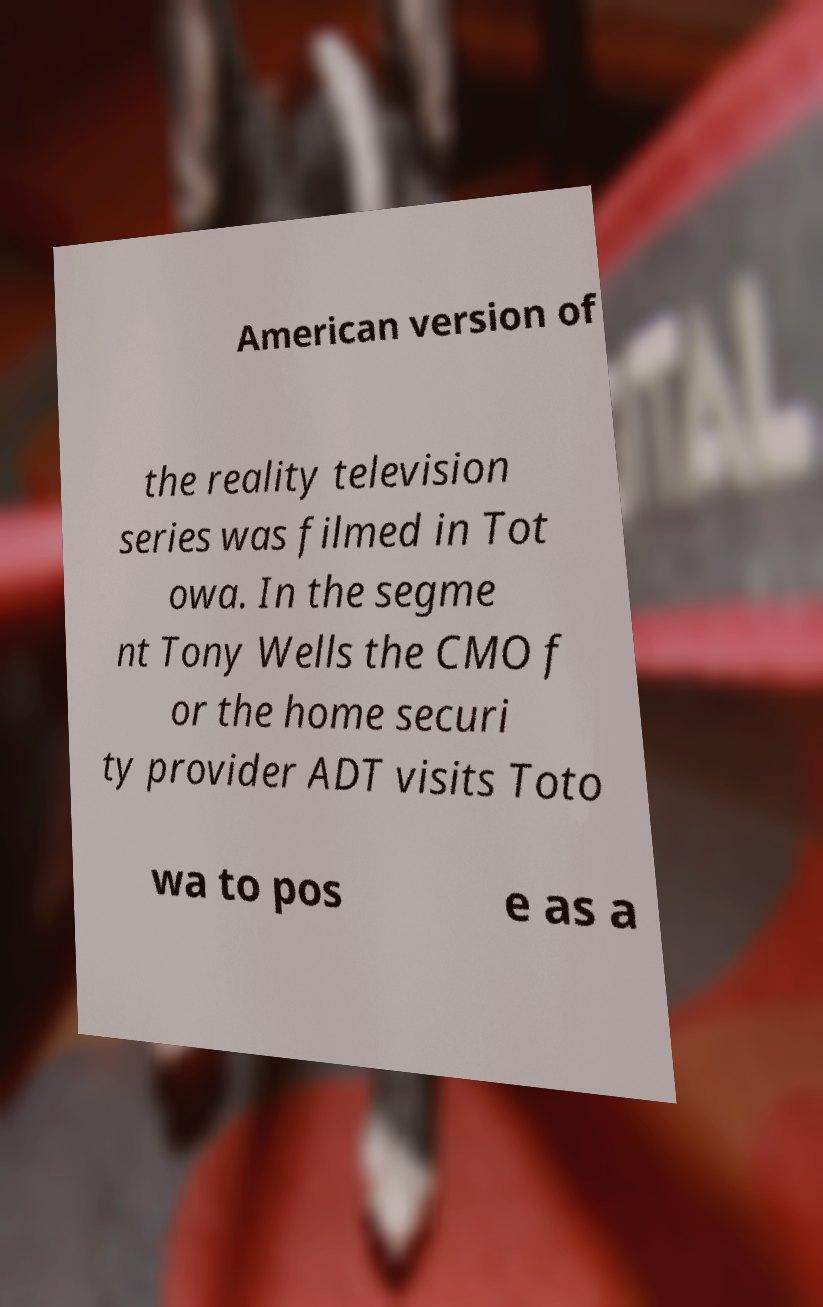There's text embedded in this image that I need extracted. Can you transcribe it verbatim? American version of the reality television series was filmed in Tot owa. In the segme nt Tony Wells the CMO f or the home securi ty provider ADT visits Toto wa to pos e as a 